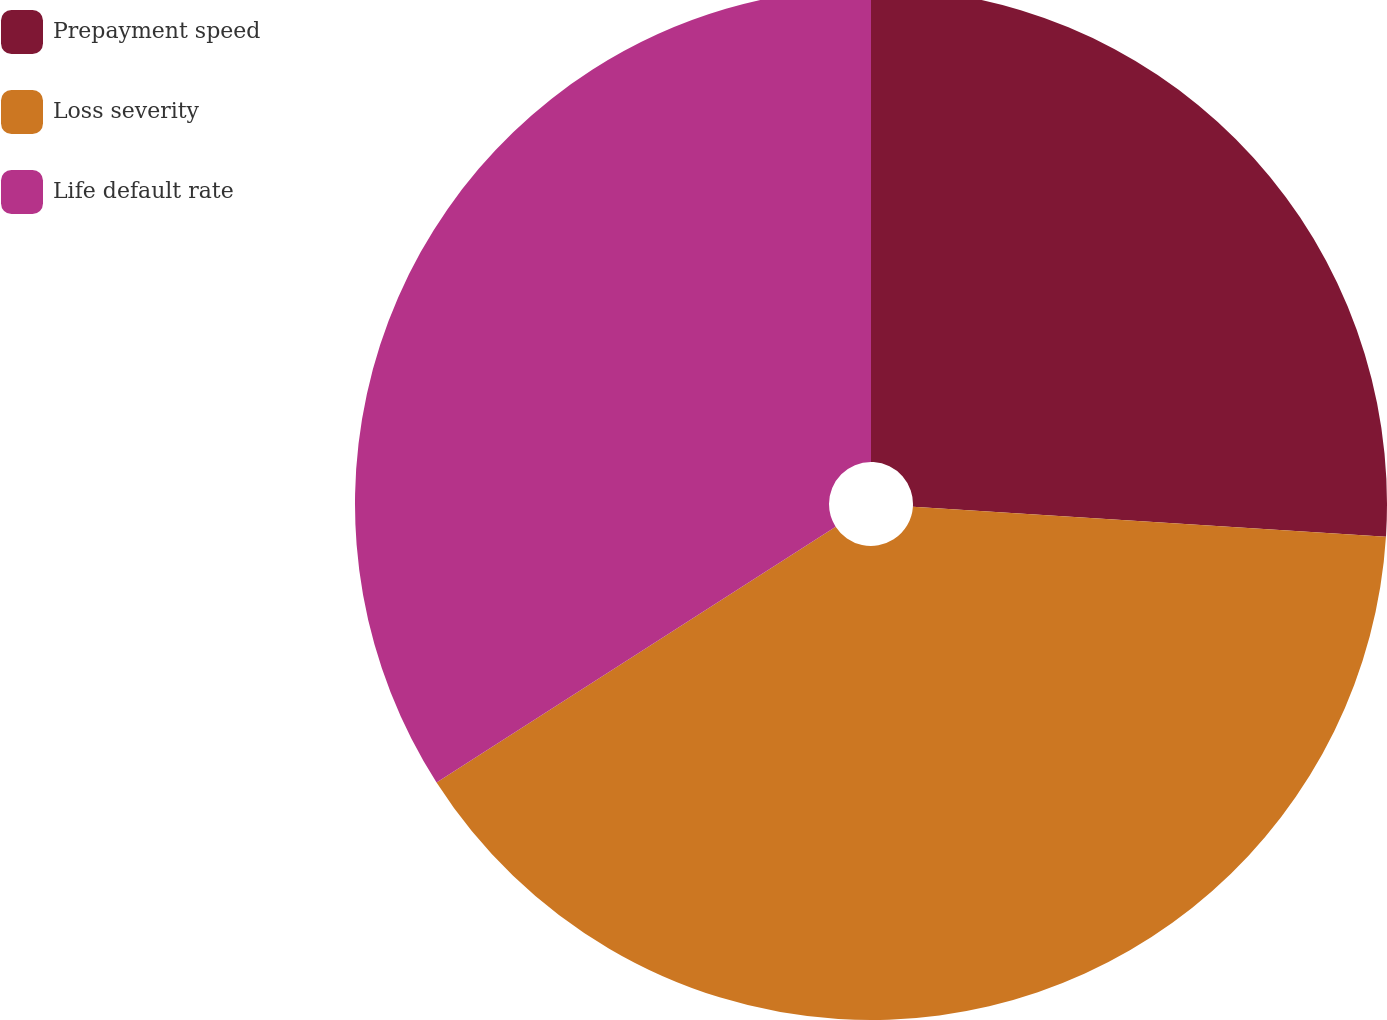Convert chart. <chart><loc_0><loc_0><loc_500><loc_500><pie_chart><fcel>Prepayment speed<fcel>Loss severity<fcel>Life default rate<nl><fcel>26.01%<fcel>39.92%<fcel>34.07%<nl></chart> 